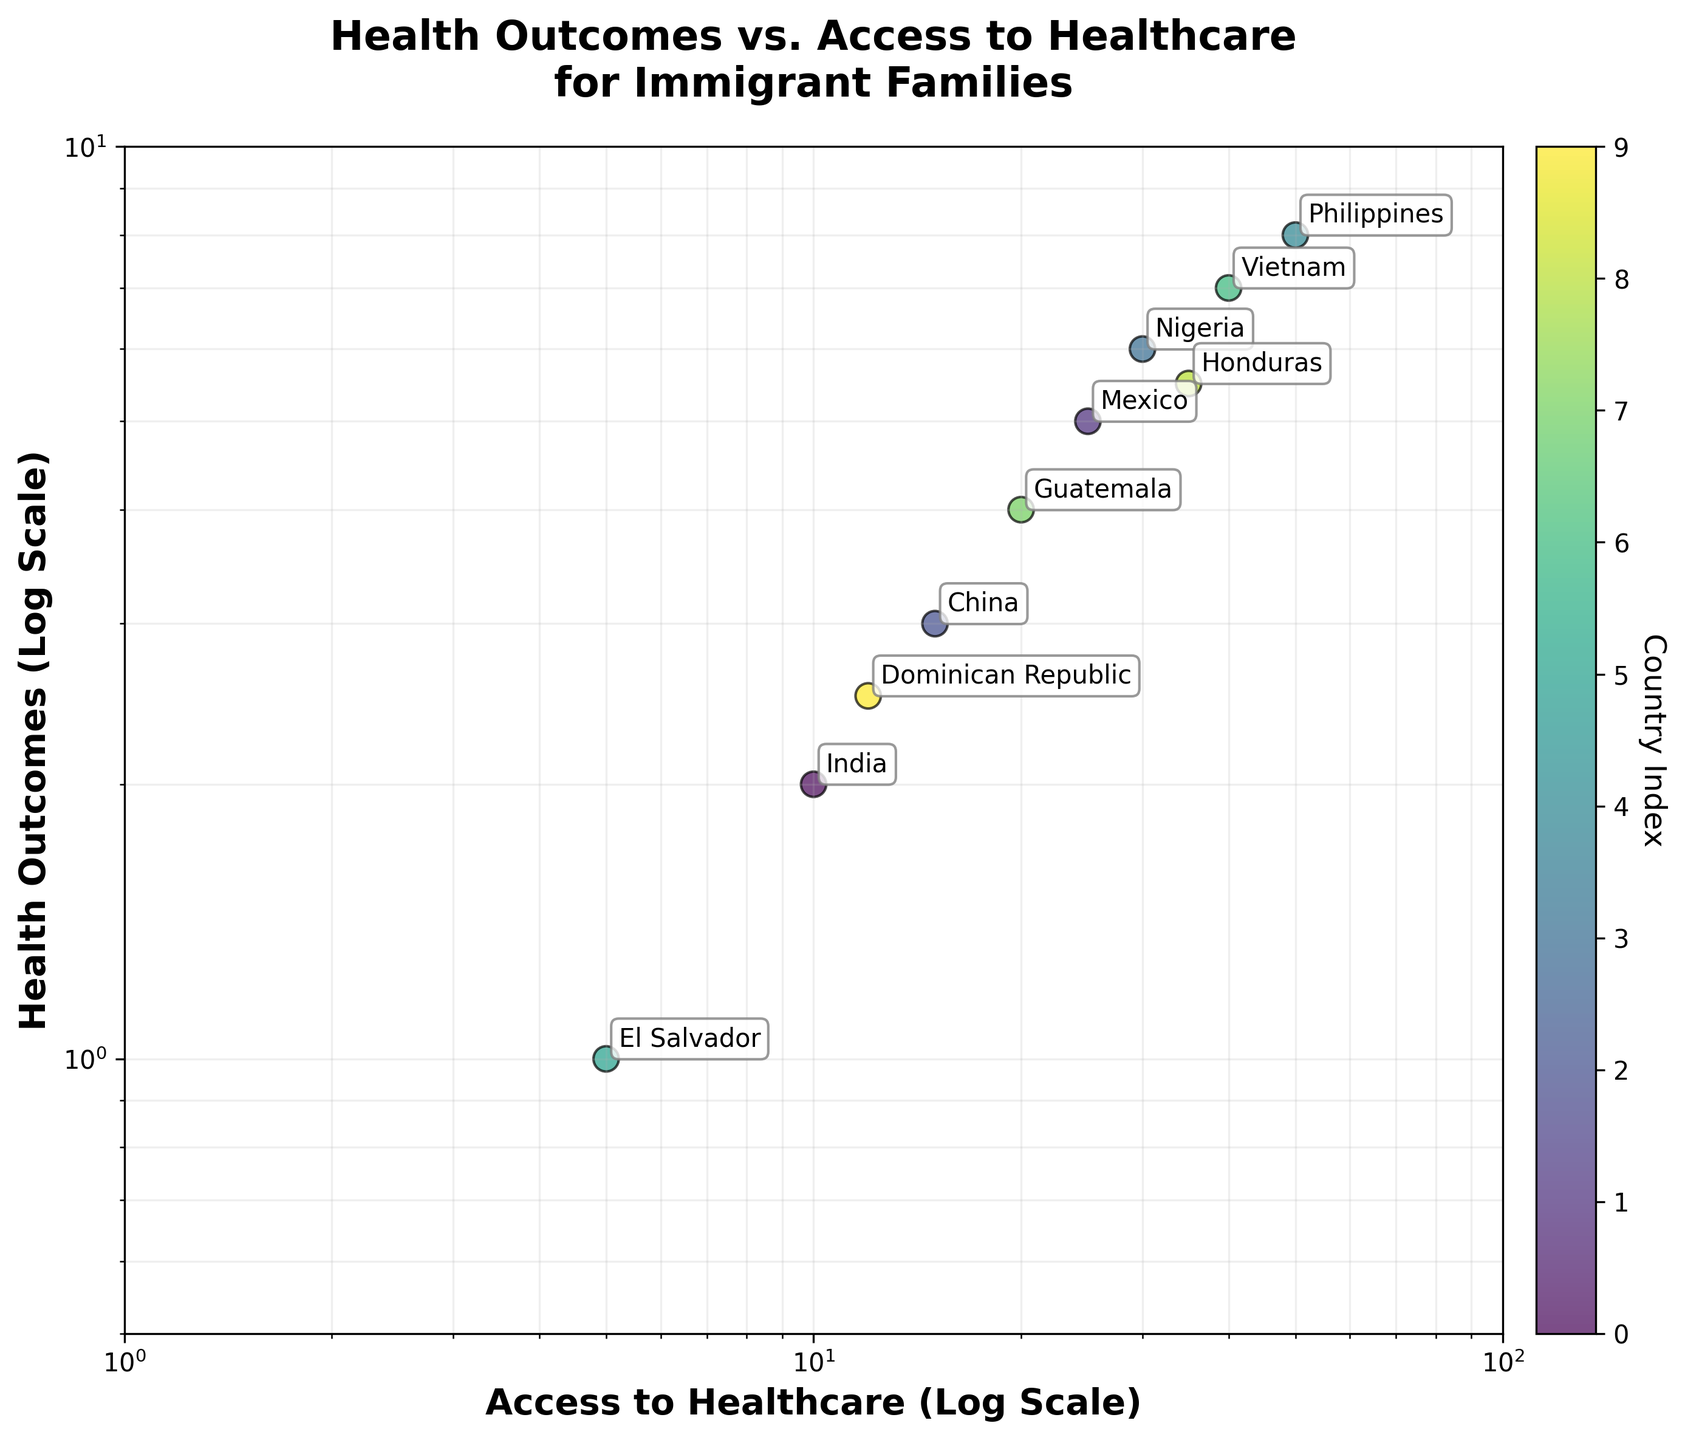What is the title of the scatter plot? The title is displayed at the top of the plot, centered and in bold. The title reads "Health Outcomes vs. Access to Healthcare for Immigrant Families."
Answer: Health Outcomes vs. Access to Healthcare for Immigrant Families How many countries are represented in the scatter plot? By counting the labels (annotations) near each data point, we can determine the number of distinct countries. There are annotations for ten different countries.
Answer: 10 What are the axes labels of the scatter plot? The labels on the x-axis and y-axis are clearly indicated as "Access to Healthcare (Log Scale)" and "Health Outcomes (Log Scale)" respectively.
Answer: Access to Healthcare (Log Scale), Health Outcomes (Log Scale) Which country has the best health outcomes and what is that value? Looking at the data points, Nigeria has the highest value on the y-axis for Health Outcomes, which is 6.
Answer: Nigeria, 6 Which country has the lowest access to healthcare? The country with the lowest x-axis value for Access to Healthcare is El Salvador, with a value of 5.
Answer: El Salvador What are the health outcomes for the country with 50 Access to Healthcare? The data point with an Access to Healthcare value of 50 is the Philippines, and its Health Outcomes value is 8.
Answer: 8 How many countries have an access to healthcare value greater than or equal to 30? By identifying the data points with Access to Healthcare values equal to or above 30, we count 4 countries: Mexico, Nigeria, Vietnam, and Philippines.
Answer: 4 What is the average Health Outcome for the countries with Access to Healthcare values of 10, 15, and 20? Referring to the data table or scatter points for these Access to Healthcare values (10, 15, 20), their corresponding Health Outcomes values are 2, 3, and 4. The average is calculated as (2 + 3 + 4)/3 = 3.
Answer: 3 Is there any country with equal Access to Healthcare and Health Outcomes values? By comparing the x-axis and y-axis values for each country, none of the data points have equal Access to Healthcare and Health Outcomes.
Answer: No Does the relationship between Access to Healthcare and Health Outcomes appear to be positive or negative? Observing the general trend in the scatter plot, as the Access to Healthcare increases, the Health Outcomes also tend to increase, indicating a positive relationship.
Answer: Positive 